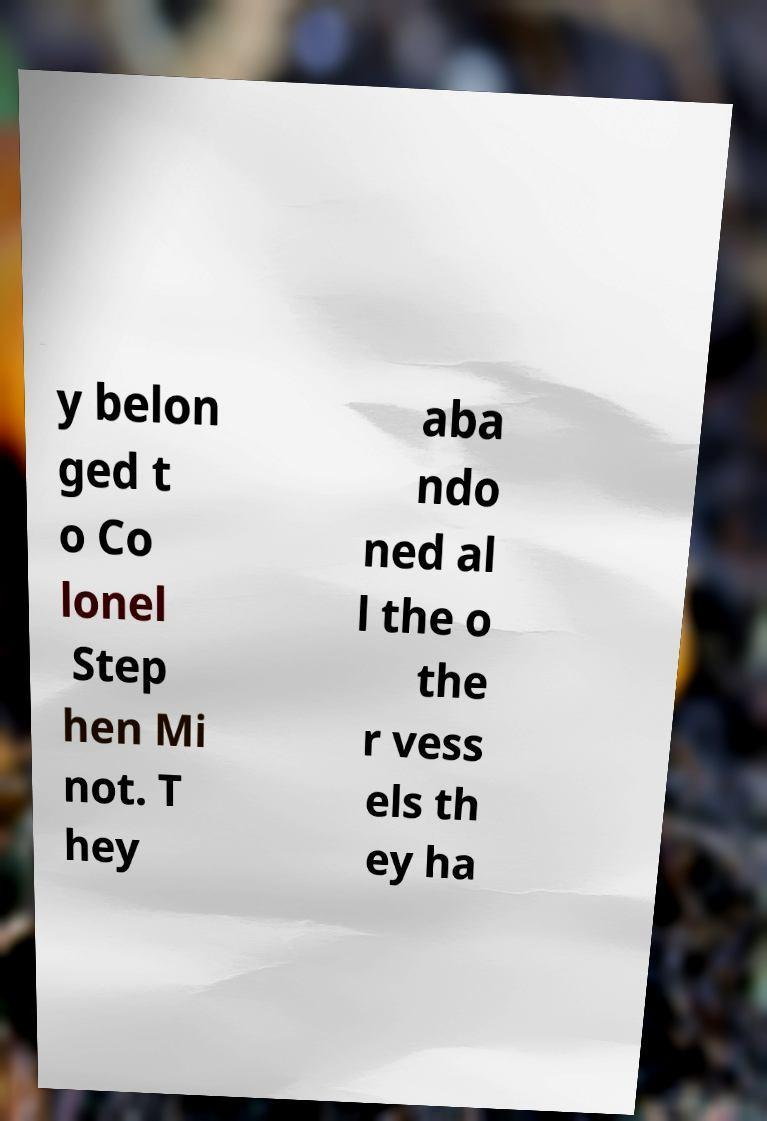Could you extract and type out the text from this image? y belon ged t o Co lonel Step hen Mi not. T hey aba ndo ned al l the o the r vess els th ey ha 